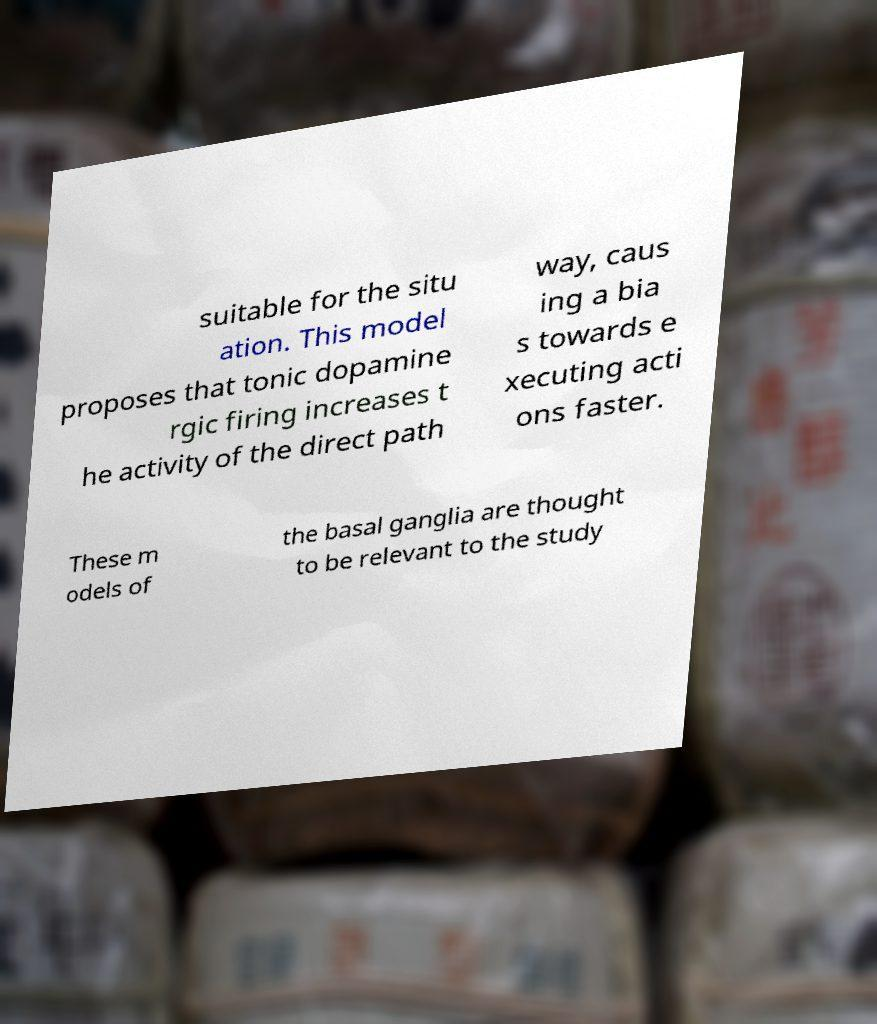Can you read and provide the text displayed in the image?This photo seems to have some interesting text. Can you extract and type it out for me? suitable for the situ ation. This model proposes that tonic dopamine rgic firing increases t he activity of the direct path way, caus ing a bia s towards e xecuting acti ons faster. These m odels of the basal ganglia are thought to be relevant to the study 